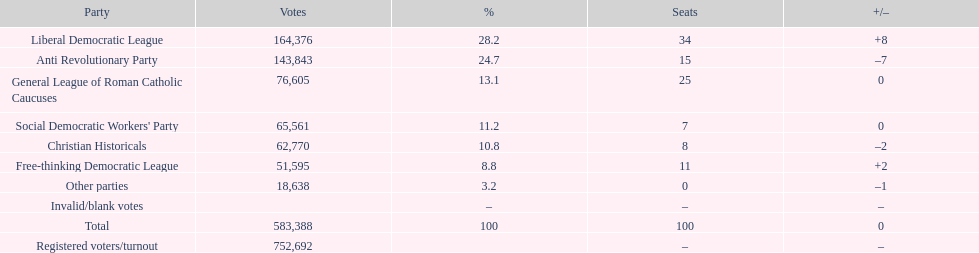Write the full table. {'header': ['Party', 'Votes', '%', 'Seats', '+/–'], 'rows': [['Liberal Democratic League', '164,376', '28.2', '34', '+8'], ['Anti Revolutionary Party', '143,843', '24.7', '15', '–7'], ['General League of Roman Catholic Caucuses', '76,605', '13.1', '25', '0'], ["Social Democratic Workers' Party", '65,561', '11.2', '7', '0'], ['Christian Historicals', '62,770', '10.8', '8', '–2'], ['Free-thinking Democratic League', '51,595', '8.8', '11', '+2'], ['Other parties', '18,638', '3.2', '0', '–1'], ['Invalid/blank votes', '', '–', '–', '–'], ['Total', '583,388', '100', '100', '0'], ['Registered voters/turnout', '752,692', '', '–', '–']]} What was the difference in the number of votes won by the liberal democratic league compared to the free-thinking democratic league? 112,781. 